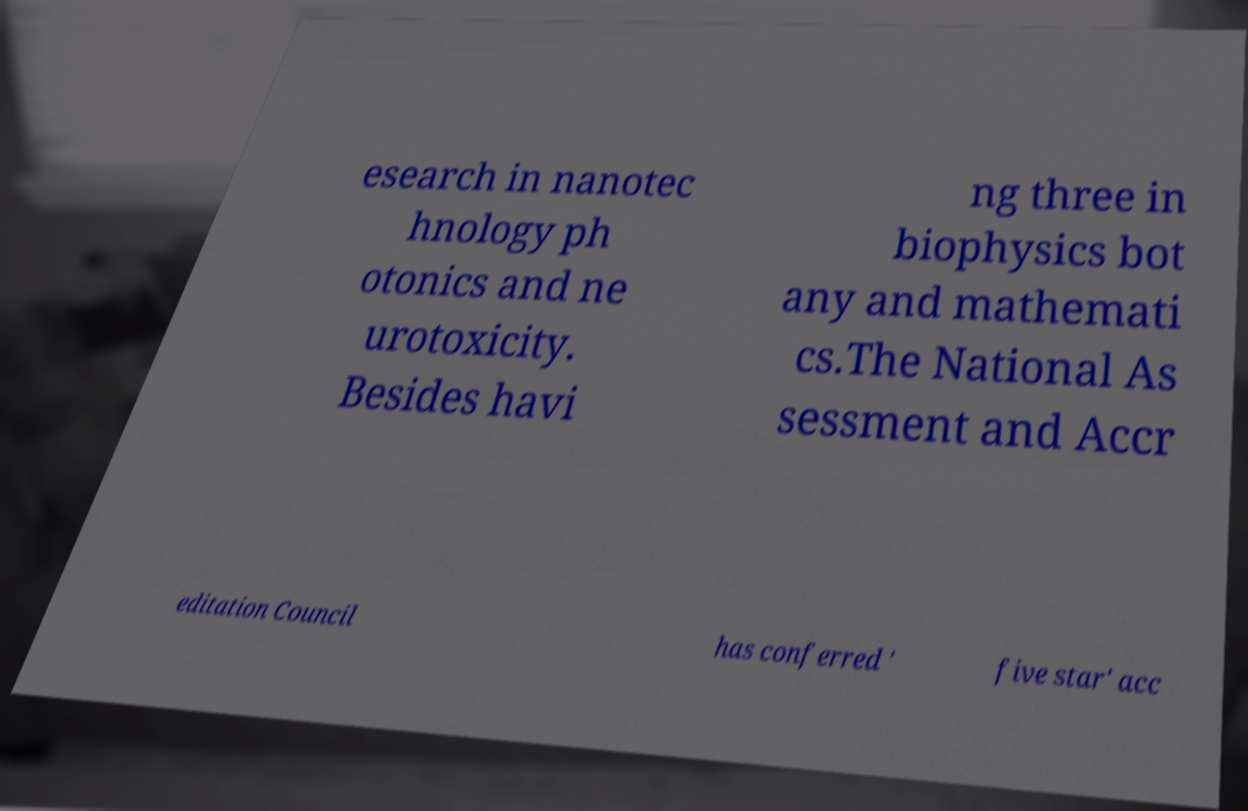I need the written content from this picture converted into text. Can you do that? esearch in nanotec hnology ph otonics and ne urotoxicity. Besides havi ng three in biophysics bot any and mathemati cs.The National As sessment and Accr editation Council has conferred ' five star' acc 